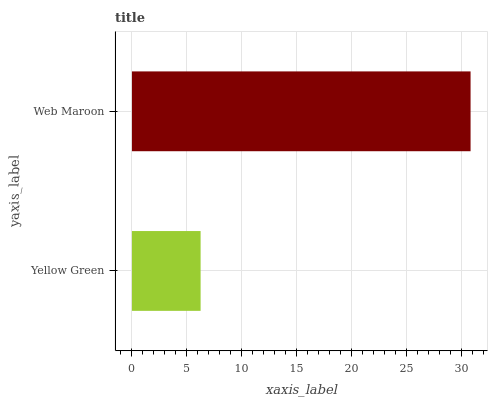Is Yellow Green the minimum?
Answer yes or no. Yes. Is Web Maroon the maximum?
Answer yes or no. Yes. Is Web Maroon the minimum?
Answer yes or no. No. Is Web Maroon greater than Yellow Green?
Answer yes or no. Yes. Is Yellow Green less than Web Maroon?
Answer yes or no. Yes. Is Yellow Green greater than Web Maroon?
Answer yes or no. No. Is Web Maroon less than Yellow Green?
Answer yes or no. No. Is Web Maroon the high median?
Answer yes or no. Yes. Is Yellow Green the low median?
Answer yes or no. Yes. Is Yellow Green the high median?
Answer yes or no. No. Is Web Maroon the low median?
Answer yes or no. No. 